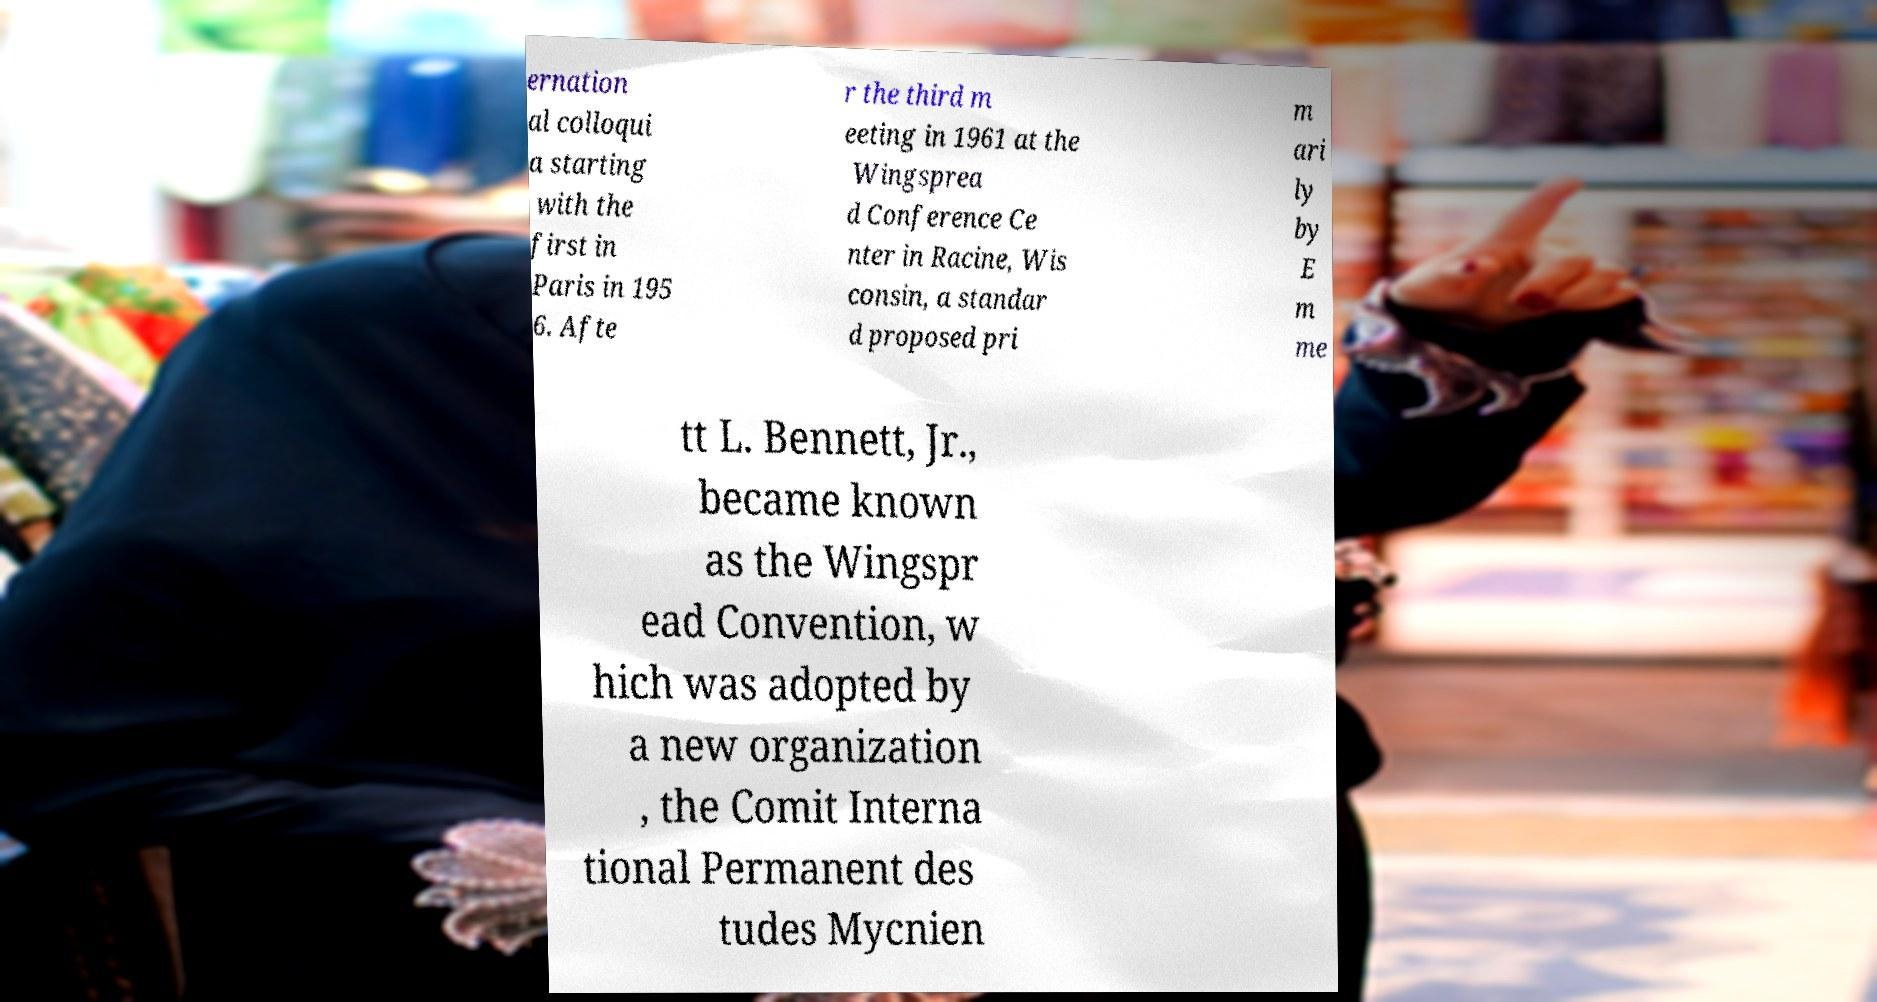Can you read and provide the text displayed in the image?This photo seems to have some interesting text. Can you extract and type it out for me? ernation al colloqui a starting with the first in Paris in 195 6. Afte r the third m eeting in 1961 at the Wingsprea d Conference Ce nter in Racine, Wis consin, a standar d proposed pri m ari ly by E m me tt L. Bennett, Jr., became known as the Wingspr ead Convention, w hich was adopted by a new organization , the Comit Interna tional Permanent des tudes Mycnien 